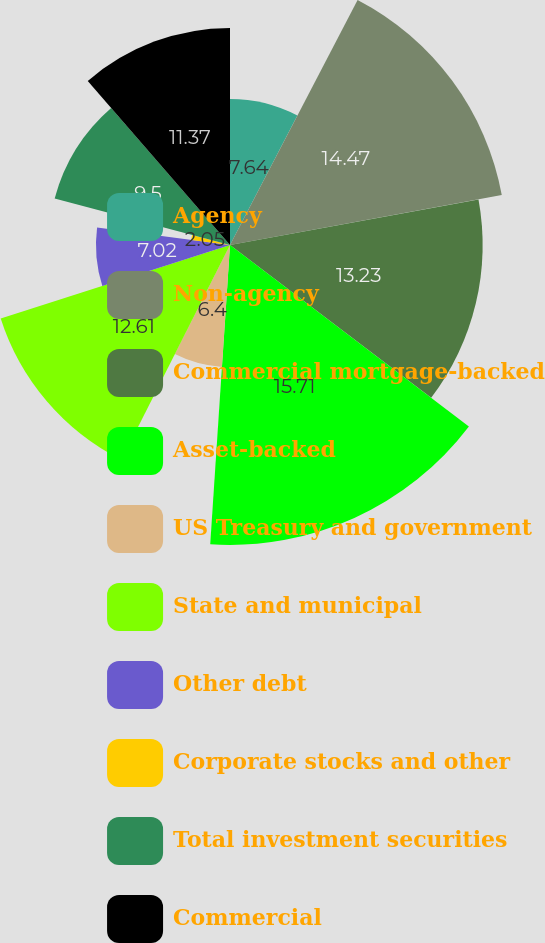Convert chart to OTSL. <chart><loc_0><loc_0><loc_500><loc_500><pie_chart><fcel>Agency<fcel>Non-agency<fcel>Commercial mortgage-backed<fcel>Asset-backed<fcel>US Treasury and government<fcel>State and municipal<fcel>Other debt<fcel>Corporate stocks and other<fcel>Total investment securities<fcel>Commercial<nl><fcel>7.64%<fcel>14.47%<fcel>13.23%<fcel>15.71%<fcel>6.4%<fcel>12.61%<fcel>7.02%<fcel>2.05%<fcel>9.5%<fcel>11.37%<nl></chart> 